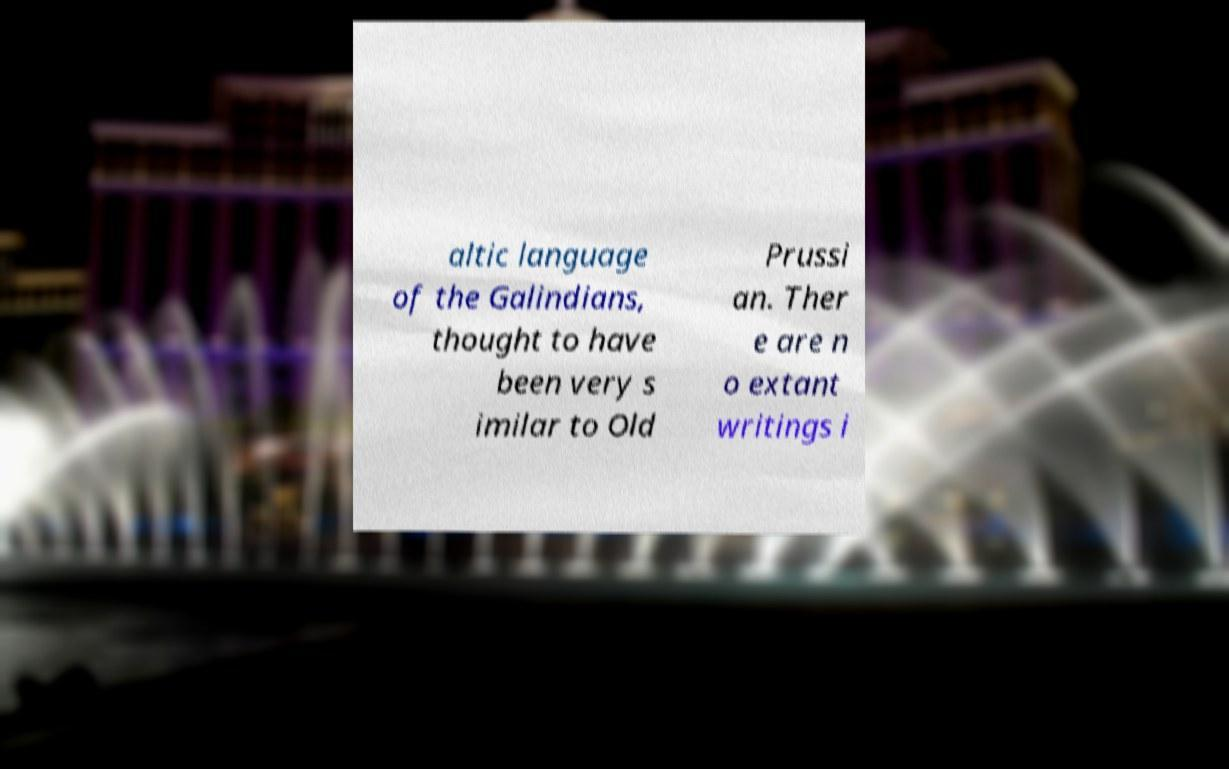Could you assist in decoding the text presented in this image and type it out clearly? altic language of the Galindians, thought to have been very s imilar to Old Prussi an. Ther e are n o extant writings i 